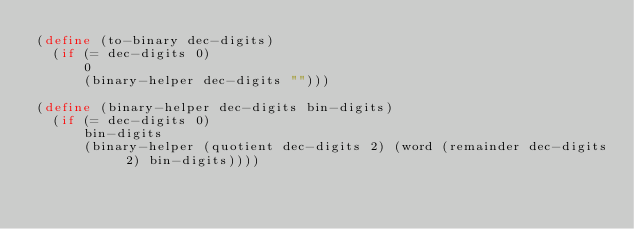Convert code to text. <code><loc_0><loc_0><loc_500><loc_500><_Scheme_>(define (to-binary dec-digits)
  (if (= dec-digits 0)
      0
      (binary-helper dec-digits "")))

(define (binary-helper dec-digits bin-digits)
  (if (= dec-digits 0)
      bin-digits
      (binary-helper (quotient dec-digits 2) (word (remainder dec-digits 2) bin-digits))))</code> 